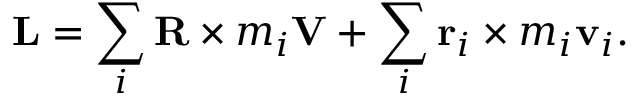<formula> <loc_0><loc_0><loc_500><loc_500>L = \sum _ { i } R \times m _ { i } V + \sum _ { i } r _ { i } \times m _ { i } v _ { i } .</formula> 